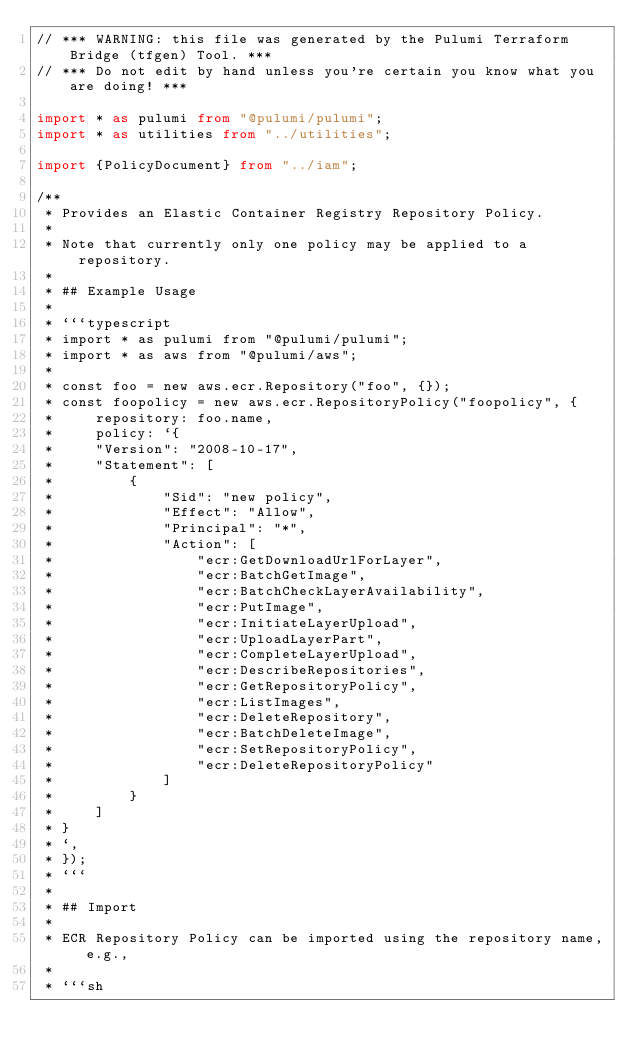Convert code to text. <code><loc_0><loc_0><loc_500><loc_500><_TypeScript_>// *** WARNING: this file was generated by the Pulumi Terraform Bridge (tfgen) Tool. ***
// *** Do not edit by hand unless you're certain you know what you are doing! ***

import * as pulumi from "@pulumi/pulumi";
import * as utilities from "../utilities";

import {PolicyDocument} from "../iam";

/**
 * Provides an Elastic Container Registry Repository Policy.
 *
 * Note that currently only one policy may be applied to a repository.
 *
 * ## Example Usage
 *
 * ```typescript
 * import * as pulumi from "@pulumi/pulumi";
 * import * as aws from "@pulumi/aws";
 *
 * const foo = new aws.ecr.Repository("foo", {});
 * const foopolicy = new aws.ecr.RepositoryPolicy("foopolicy", {
 *     repository: foo.name,
 *     policy: `{
 *     "Version": "2008-10-17",
 *     "Statement": [
 *         {
 *             "Sid": "new policy",
 *             "Effect": "Allow",
 *             "Principal": "*",
 *             "Action": [
 *                 "ecr:GetDownloadUrlForLayer",
 *                 "ecr:BatchGetImage",
 *                 "ecr:BatchCheckLayerAvailability",
 *                 "ecr:PutImage",
 *                 "ecr:InitiateLayerUpload",
 *                 "ecr:UploadLayerPart",
 *                 "ecr:CompleteLayerUpload",
 *                 "ecr:DescribeRepositories",
 *                 "ecr:GetRepositoryPolicy",
 *                 "ecr:ListImages",
 *                 "ecr:DeleteRepository",
 *                 "ecr:BatchDeleteImage",
 *                 "ecr:SetRepositoryPolicy",
 *                 "ecr:DeleteRepositoryPolicy"
 *             ]
 *         }
 *     ]
 * }
 * `,
 * });
 * ```
 *
 * ## Import
 *
 * ECR Repository Policy can be imported using the repository name, e.g.,
 *
 * ```sh</code> 